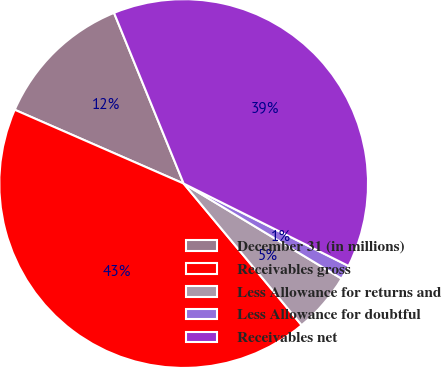<chart> <loc_0><loc_0><loc_500><loc_500><pie_chart><fcel>December 31 (in millions)<fcel>Receivables gross<fcel>Less Allowance for returns and<fcel>Less Allowance for doubtful<fcel>Receivables net<nl><fcel>12.28%<fcel>42.61%<fcel>5.32%<fcel>1.25%<fcel>38.54%<nl></chart> 